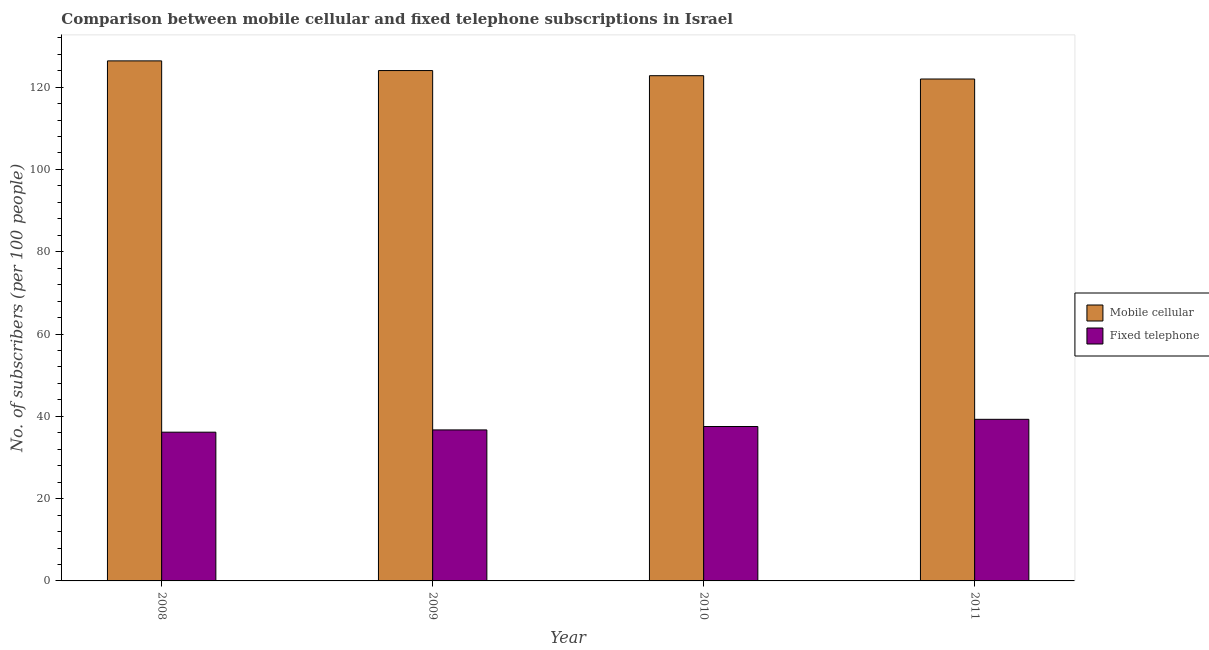How many different coloured bars are there?
Keep it short and to the point. 2. How many groups of bars are there?
Give a very brief answer. 4. Are the number of bars on each tick of the X-axis equal?
Ensure brevity in your answer.  Yes. How many bars are there on the 1st tick from the left?
Offer a very short reply. 2. How many bars are there on the 2nd tick from the right?
Provide a short and direct response. 2. What is the number of mobile cellular subscribers in 2009?
Offer a very short reply. 124.03. Across all years, what is the maximum number of mobile cellular subscribers?
Your response must be concise. 126.39. Across all years, what is the minimum number of fixed telephone subscribers?
Your answer should be compact. 36.15. In which year was the number of mobile cellular subscribers minimum?
Your response must be concise. 2011. What is the total number of mobile cellular subscribers in the graph?
Offer a terse response. 495.18. What is the difference between the number of fixed telephone subscribers in 2008 and that in 2010?
Keep it short and to the point. -1.38. What is the difference between the number of fixed telephone subscribers in 2011 and the number of mobile cellular subscribers in 2010?
Offer a very short reply. 1.75. What is the average number of mobile cellular subscribers per year?
Provide a short and direct response. 123.8. In the year 2010, what is the difference between the number of fixed telephone subscribers and number of mobile cellular subscribers?
Offer a terse response. 0. What is the ratio of the number of mobile cellular subscribers in 2008 to that in 2010?
Provide a succinct answer. 1.03. Is the difference between the number of mobile cellular subscribers in 2008 and 2010 greater than the difference between the number of fixed telephone subscribers in 2008 and 2010?
Keep it short and to the point. No. What is the difference between the highest and the second highest number of mobile cellular subscribers?
Your answer should be compact. 2.35. What is the difference between the highest and the lowest number of fixed telephone subscribers?
Provide a succinct answer. 3.12. What does the 2nd bar from the left in 2011 represents?
Keep it short and to the point. Fixed telephone. What does the 1st bar from the right in 2010 represents?
Make the answer very short. Fixed telephone. How many bars are there?
Ensure brevity in your answer.  8. Are all the bars in the graph horizontal?
Provide a short and direct response. No. Are the values on the major ticks of Y-axis written in scientific E-notation?
Provide a short and direct response. No. Does the graph contain any zero values?
Provide a short and direct response. No. Does the graph contain grids?
Provide a short and direct response. No. Where does the legend appear in the graph?
Provide a succinct answer. Center right. How are the legend labels stacked?
Provide a succinct answer. Vertical. What is the title of the graph?
Provide a succinct answer. Comparison between mobile cellular and fixed telephone subscriptions in Israel. What is the label or title of the Y-axis?
Provide a succinct answer. No. of subscribers (per 100 people). What is the No. of subscribers (per 100 people) in Mobile cellular in 2008?
Ensure brevity in your answer.  126.39. What is the No. of subscribers (per 100 people) in Fixed telephone in 2008?
Make the answer very short. 36.15. What is the No. of subscribers (per 100 people) in Mobile cellular in 2009?
Make the answer very short. 124.03. What is the No. of subscribers (per 100 people) of Fixed telephone in 2009?
Your answer should be very brief. 36.7. What is the No. of subscribers (per 100 people) in Mobile cellular in 2010?
Provide a succinct answer. 122.78. What is the No. of subscribers (per 100 people) in Fixed telephone in 2010?
Your answer should be very brief. 37.53. What is the No. of subscribers (per 100 people) of Mobile cellular in 2011?
Ensure brevity in your answer.  121.98. What is the No. of subscribers (per 100 people) of Fixed telephone in 2011?
Your response must be concise. 39.27. Across all years, what is the maximum No. of subscribers (per 100 people) of Mobile cellular?
Give a very brief answer. 126.39. Across all years, what is the maximum No. of subscribers (per 100 people) in Fixed telephone?
Keep it short and to the point. 39.27. Across all years, what is the minimum No. of subscribers (per 100 people) of Mobile cellular?
Your response must be concise. 121.98. Across all years, what is the minimum No. of subscribers (per 100 people) of Fixed telephone?
Your response must be concise. 36.15. What is the total No. of subscribers (per 100 people) of Mobile cellular in the graph?
Provide a short and direct response. 495.18. What is the total No. of subscribers (per 100 people) of Fixed telephone in the graph?
Provide a short and direct response. 149.65. What is the difference between the No. of subscribers (per 100 people) of Mobile cellular in 2008 and that in 2009?
Your answer should be very brief. 2.35. What is the difference between the No. of subscribers (per 100 people) of Fixed telephone in 2008 and that in 2009?
Offer a terse response. -0.55. What is the difference between the No. of subscribers (per 100 people) in Mobile cellular in 2008 and that in 2010?
Provide a short and direct response. 3.6. What is the difference between the No. of subscribers (per 100 people) of Fixed telephone in 2008 and that in 2010?
Offer a very short reply. -1.38. What is the difference between the No. of subscribers (per 100 people) in Mobile cellular in 2008 and that in 2011?
Provide a short and direct response. 4.41. What is the difference between the No. of subscribers (per 100 people) in Fixed telephone in 2008 and that in 2011?
Make the answer very short. -3.12. What is the difference between the No. of subscribers (per 100 people) of Mobile cellular in 2009 and that in 2010?
Provide a succinct answer. 1.25. What is the difference between the No. of subscribers (per 100 people) of Fixed telephone in 2009 and that in 2010?
Your response must be concise. -0.83. What is the difference between the No. of subscribers (per 100 people) in Mobile cellular in 2009 and that in 2011?
Provide a succinct answer. 2.06. What is the difference between the No. of subscribers (per 100 people) in Fixed telephone in 2009 and that in 2011?
Offer a very short reply. -2.57. What is the difference between the No. of subscribers (per 100 people) in Mobile cellular in 2010 and that in 2011?
Provide a short and direct response. 0.81. What is the difference between the No. of subscribers (per 100 people) in Fixed telephone in 2010 and that in 2011?
Your answer should be very brief. -1.75. What is the difference between the No. of subscribers (per 100 people) in Mobile cellular in 2008 and the No. of subscribers (per 100 people) in Fixed telephone in 2009?
Provide a short and direct response. 89.69. What is the difference between the No. of subscribers (per 100 people) in Mobile cellular in 2008 and the No. of subscribers (per 100 people) in Fixed telephone in 2010?
Offer a very short reply. 88.86. What is the difference between the No. of subscribers (per 100 people) of Mobile cellular in 2008 and the No. of subscribers (per 100 people) of Fixed telephone in 2011?
Offer a very short reply. 87.11. What is the difference between the No. of subscribers (per 100 people) of Mobile cellular in 2009 and the No. of subscribers (per 100 people) of Fixed telephone in 2010?
Offer a terse response. 86.51. What is the difference between the No. of subscribers (per 100 people) of Mobile cellular in 2009 and the No. of subscribers (per 100 people) of Fixed telephone in 2011?
Your answer should be compact. 84.76. What is the difference between the No. of subscribers (per 100 people) in Mobile cellular in 2010 and the No. of subscribers (per 100 people) in Fixed telephone in 2011?
Keep it short and to the point. 83.51. What is the average No. of subscribers (per 100 people) of Mobile cellular per year?
Your response must be concise. 123.8. What is the average No. of subscribers (per 100 people) of Fixed telephone per year?
Make the answer very short. 37.41. In the year 2008, what is the difference between the No. of subscribers (per 100 people) of Mobile cellular and No. of subscribers (per 100 people) of Fixed telephone?
Provide a succinct answer. 90.24. In the year 2009, what is the difference between the No. of subscribers (per 100 people) in Mobile cellular and No. of subscribers (per 100 people) in Fixed telephone?
Provide a short and direct response. 87.33. In the year 2010, what is the difference between the No. of subscribers (per 100 people) of Mobile cellular and No. of subscribers (per 100 people) of Fixed telephone?
Make the answer very short. 85.25. In the year 2011, what is the difference between the No. of subscribers (per 100 people) of Mobile cellular and No. of subscribers (per 100 people) of Fixed telephone?
Offer a terse response. 82.7. What is the ratio of the No. of subscribers (per 100 people) in Fixed telephone in 2008 to that in 2009?
Provide a succinct answer. 0.98. What is the ratio of the No. of subscribers (per 100 people) in Mobile cellular in 2008 to that in 2010?
Your answer should be compact. 1.03. What is the ratio of the No. of subscribers (per 100 people) of Fixed telephone in 2008 to that in 2010?
Your answer should be very brief. 0.96. What is the ratio of the No. of subscribers (per 100 people) in Mobile cellular in 2008 to that in 2011?
Provide a succinct answer. 1.04. What is the ratio of the No. of subscribers (per 100 people) of Fixed telephone in 2008 to that in 2011?
Ensure brevity in your answer.  0.92. What is the ratio of the No. of subscribers (per 100 people) of Mobile cellular in 2009 to that in 2010?
Give a very brief answer. 1.01. What is the ratio of the No. of subscribers (per 100 people) of Fixed telephone in 2009 to that in 2010?
Your answer should be very brief. 0.98. What is the ratio of the No. of subscribers (per 100 people) of Mobile cellular in 2009 to that in 2011?
Your answer should be compact. 1.02. What is the ratio of the No. of subscribers (per 100 people) of Fixed telephone in 2009 to that in 2011?
Your response must be concise. 0.93. What is the ratio of the No. of subscribers (per 100 people) of Mobile cellular in 2010 to that in 2011?
Make the answer very short. 1.01. What is the ratio of the No. of subscribers (per 100 people) in Fixed telephone in 2010 to that in 2011?
Make the answer very short. 0.96. What is the difference between the highest and the second highest No. of subscribers (per 100 people) of Mobile cellular?
Your answer should be compact. 2.35. What is the difference between the highest and the second highest No. of subscribers (per 100 people) of Fixed telephone?
Keep it short and to the point. 1.75. What is the difference between the highest and the lowest No. of subscribers (per 100 people) of Mobile cellular?
Your response must be concise. 4.41. What is the difference between the highest and the lowest No. of subscribers (per 100 people) of Fixed telephone?
Your answer should be very brief. 3.12. 